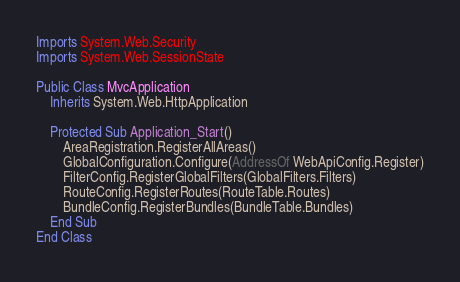<code> <loc_0><loc_0><loc_500><loc_500><_VisualBasic_>Imports System.Web.Security
Imports System.Web.SessionState

Public Class MvcApplication
    Inherits System.Web.HttpApplication

    Protected Sub Application_Start()
        AreaRegistration.RegisterAllAreas()
        GlobalConfiguration.Configure(AddressOf WebApiConfig.Register)
        FilterConfig.RegisterGlobalFilters(GlobalFilters.Filters)
        RouteConfig.RegisterRoutes(RouteTable.Routes)
        BundleConfig.RegisterBundles(BundleTable.Bundles)
    End Sub
End Class
</code> 